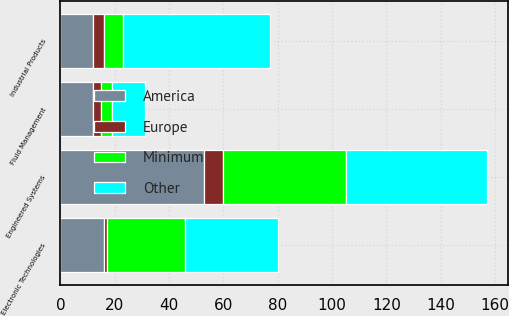Convert chart to OTSL. <chart><loc_0><loc_0><loc_500><loc_500><stacked_bar_chart><ecel><fcel>Industrial Products<fcel>Engineered Systems<fcel>Fluid Management<fcel>Electronic Technologies<nl><fcel>Other<fcel>54<fcel>52<fcel>12<fcel>34<nl><fcel>America<fcel>12<fcel>53<fcel>12<fcel>16<nl><fcel>Minimum<fcel>7<fcel>45<fcel>4<fcel>29<nl><fcel>Europe<fcel>4<fcel>7<fcel>3<fcel>1<nl></chart> 